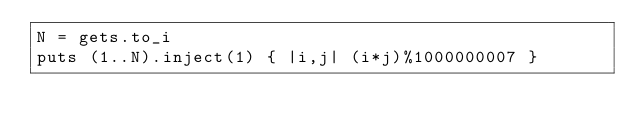<code> <loc_0><loc_0><loc_500><loc_500><_Ruby_>N = gets.to_i
puts (1..N).inject(1) { |i,j| (i*j)%1000000007 }</code> 